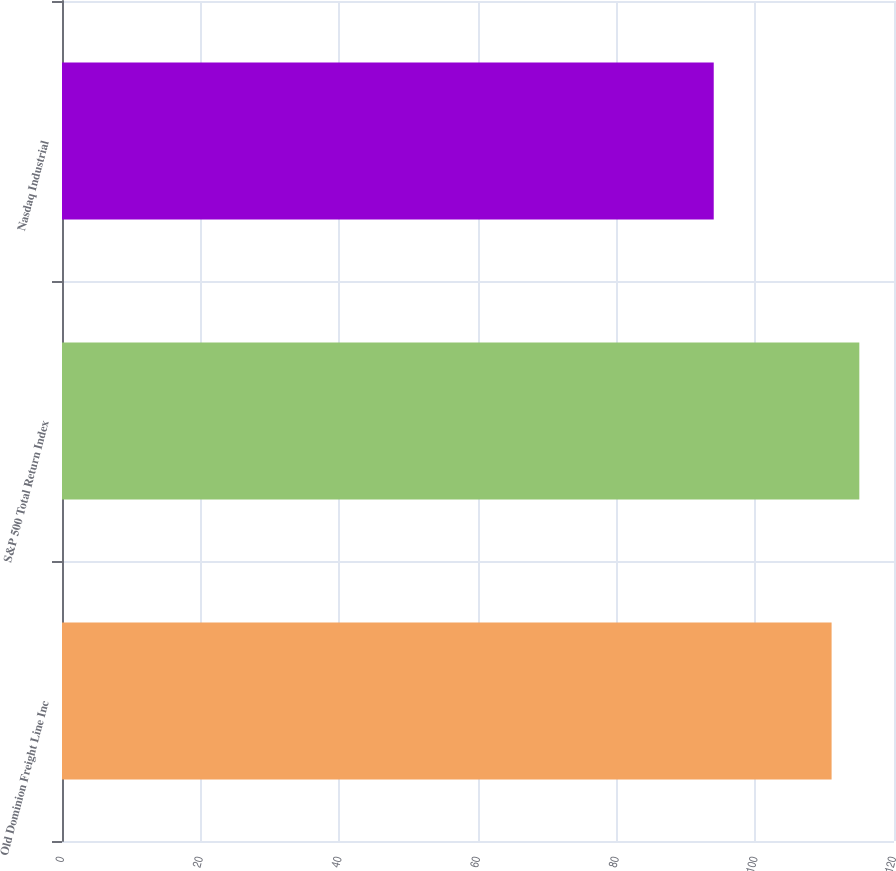Convert chart. <chart><loc_0><loc_0><loc_500><loc_500><bar_chart><fcel>Old Dominion Freight Line Inc<fcel>S&P 500 Total Return Index<fcel>Nasdaq Industrial<nl><fcel>111<fcel>115<fcel>94<nl></chart> 